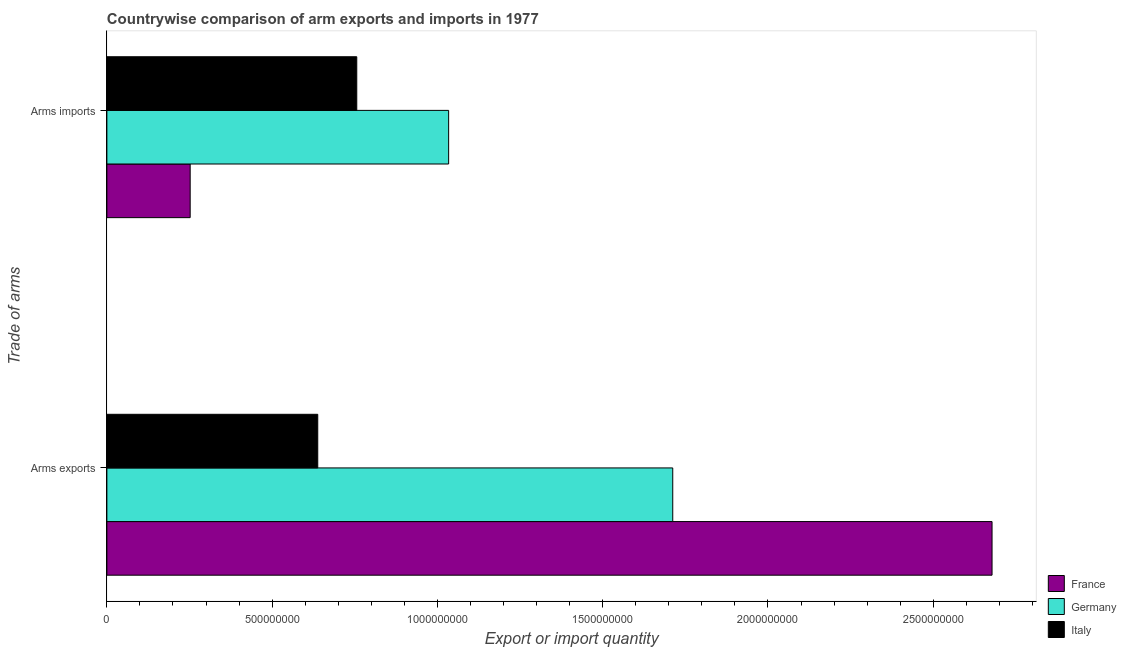Are the number of bars per tick equal to the number of legend labels?
Ensure brevity in your answer.  Yes. Are the number of bars on each tick of the Y-axis equal?
Your response must be concise. Yes. What is the label of the 1st group of bars from the top?
Offer a terse response. Arms imports. What is the arms exports in Italy?
Give a very brief answer. 6.38e+08. Across all countries, what is the maximum arms exports?
Offer a very short reply. 2.68e+09. Across all countries, what is the minimum arms exports?
Your answer should be very brief. 6.38e+08. In which country was the arms exports minimum?
Offer a very short reply. Italy. What is the total arms exports in the graph?
Your answer should be compact. 5.03e+09. What is the difference between the arms imports in Italy and that in Germany?
Provide a succinct answer. -2.78e+08. What is the difference between the arms imports in Italy and the arms exports in France?
Offer a very short reply. -1.92e+09. What is the average arms exports per country?
Make the answer very short. 1.68e+09. What is the difference between the arms imports and arms exports in Germany?
Offer a terse response. -6.78e+08. What is the ratio of the arms exports in Germany to that in Italy?
Offer a terse response. 2.68. In how many countries, is the arms imports greater than the average arms imports taken over all countries?
Offer a terse response. 2. What does the 3rd bar from the top in Arms exports represents?
Ensure brevity in your answer.  France. What does the 1st bar from the bottom in Arms imports represents?
Offer a very short reply. France. How many bars are there?
Your answer should be very brief. 6. How many countries are there in the graph?
Provide a succinct answer. 3. How many legend labels are there?
Keep it short and to the point. 3. How are the legend labels stacked?
Make the answer very short. Vertical. What is the title of the graph?
Your response must be concise. Countrywise comparison of arm exports and imports in 1977. Does "Bangladesh" appear as one of the legend labels in the graph?
Your answer should be compact. No. What is the label or title of the X-axis?
Ensure brevity in your answer.  Export or import quantity. What is the label or title of the Y-axis?
Your response must be concise. Trade of arms. What is the Export or import quantity of France in Arms exports?
Give a very brief answer. 2.68e+09. What is the Export or import quantity of Germany in Arms exports?
Your answer should be compact. 1.71e+09. What is the Export or import quantity of Italy in Arms exports?
Your answer should be very brief. 6.38e+08. What is the Export or import quantity in France in Arms imports?
Make the answer very short. 2.52e+08. What is the Export or import quantity of Germany in Arms imports?
Keep it short and to the point. 1.03e+09. What is the Export or import quantity of Italy in Arms imports?
Make the answer very short. 7.56e+08. Across all Trade of arms, what is the maximum Export or import quantity of France?
Offer a terse response. 2.68e+09. Across all Trade of arms, what is the maximum Export or import quantity in Germany?
Ensure brevity in your answer.  1.71e+09. Across all Trade of arms, what is the maximum Export or import quantity of Italy?
Your answer should be compact. 7.56e+08. Across all Trade of arms, what is the minimum Export or import quantity in France?
Provide a short and direct response. 2.52e+08. Across all Trade of arms, what is the minimum Export or import quantity of Germany?
Your answer should be compact. 1.03e+09. Across all Trade of arms, what is the minimum Export or import quantity of Italy?
Provide a short and direct response. 6.38e+08. What is the total Export or import quantity in France in the graph?
Provide a short and direct response. 2.93e+09. What is the total Export or import quantity of Germany in the graph?
Provide a short and direct response. 2.75e+09. What is the total Export or import quantity in Italy in the graph?
Make the answer very short. 1.39e+09. What is the difference between the Export or import quantity of France in Arms exports and that in Arms imports?
Your response must be concise. 2.43e+09. What is the difference between the Export or import quantity in Germany in Arms exports and that in Arms imports?
Give a very brief answer. 6.78e+08. What is the difference between the Export or import quantity of Italy in Arms exports and that in Arms imports?
Ensure brevity in your answer.  -1.18e+08. What is the difference between the Export or import quantity in France in Arms exports and the Export or import quantity in Germany in Arms imports?
Provide a succinct answer. 1.64e+09. What is the difference between the Export or import quantity of France in Arms exports and the Export or import quantity of Italy in Arms imports?
Your response must be concise. 1.92e+09. What is the difference between the Export or import quantity in Germany in Arms exports and the Export or import quantity in Italy in Arms imports?
Your response must be concise. 9.56e+08. What is the average Export or import quantity of France per Trade of arms?
Keep it short and to the point. 1.46e+09. What is the average Export or import quantity of Germany per Trade of arms?
Your response must be concise. 1.37e+09. What is the average Export or import quantity of Italy per Trade of arms?
Your response must be concise. 6.97e+08. What is the difference between the Export or import quantity of France and Export or import quantity of Germany in Arms exports?
Offer a very short reply. 9.66e+08. What is the difference between the Export or import quantity in France and Export or import quantity in Italy in Arms exports?
Provide a short and direct response. 2.04e+09. What is the difference between the Export or import quantity in Germany and Export or import quantity in Italy in Arms exports?
Make the answer very short. 1.07e+09. What is the difference between the Export or import quantity of France and Export or import quantity of Germany in Arms imports?
Offer a terse response. -7.82e+08. What is the difference between the Export or import quantity in France and Export or import quantity in Italy in Arms imports?
Your answer should be compact. -5.04e+08. What is the difference between the Export or import quantity of Germany and Export or import quantity of Italy in Arms imports?
Provide a short and direct response. 2.78e+08. What is the ratio of the Export or import quantity of France in Arms exports to that in Arms imports?
Provide a short and direct response. 10.63. What is the ratio of the Export or import quantity in Germany in Arms exports to that in Arms imports?
Keep it short and to the point. 1.66. What is the ratio of the Export or import quantity in Italy in Arms exports to that in Arms imports?
Ensure brevity in your answer.  0.84. What is the difference between the highest and the second highest Export or import quantity of France?
Ensure brevity in your answer.  2.43e+09. What is the difference between the highest and the second highest Export or import quantity in Germany?
Provide a short and direct response. 6.78e+08. What is the difference between the highest and the second highest Export or import quantity in Italy?
Keep it short and to the point. 1.18e+08. What is the difference between the highest and the lowest Export or import quantity of France?
Offer a very short reply. 2.43e+09. What is the difference between the highest and the lowest Export or import quantity in Germany?
Your response must be concise. 6.78e+08. What is the difference between the highest and the lowest Export or import quantity of Italy?
Offer a terse response. 1.18e+08. 